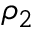<formula> <loc_0><loc_0><loc_500><loc_500>\rho _ { 2 }</formula> 